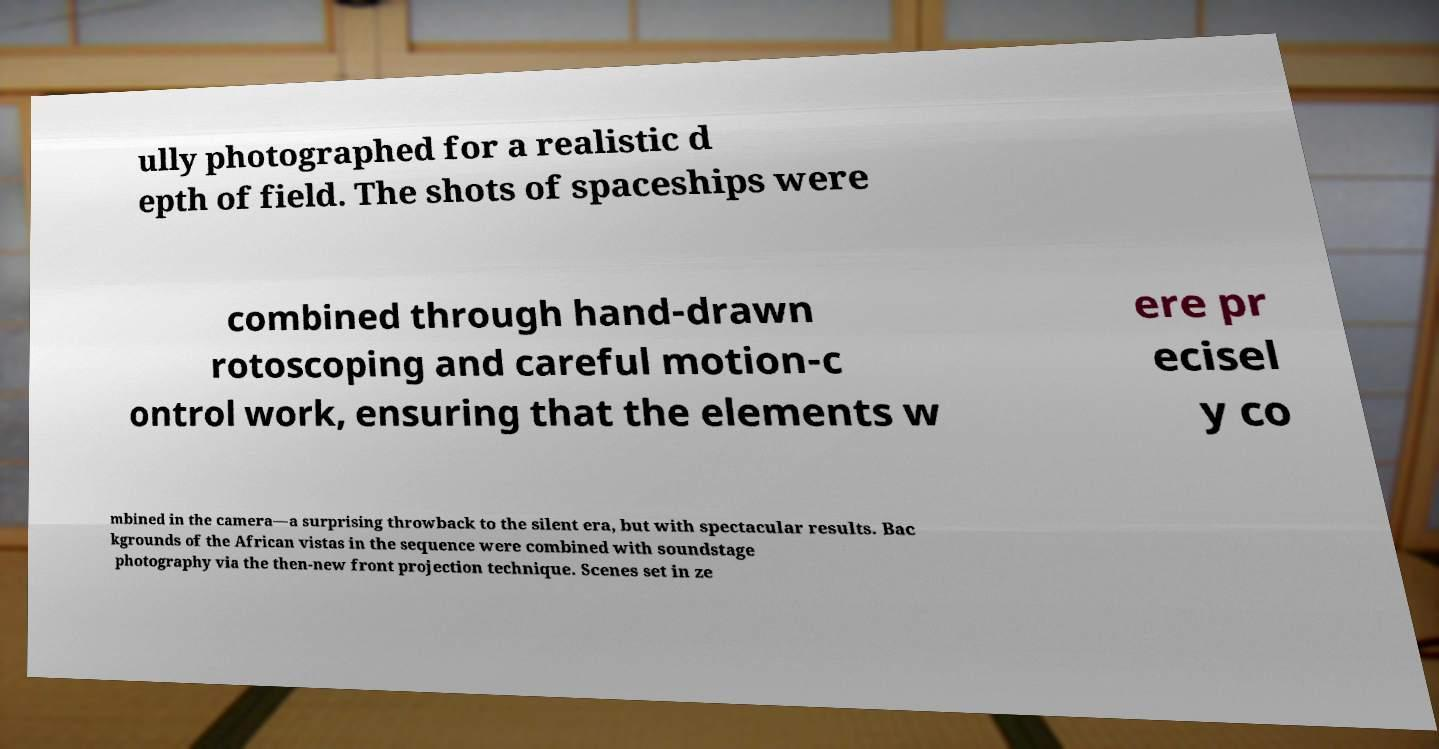Could you assist in decoding the text presented in this image and type it out clearly? ully photographed for a realistic d epth of field. The shots of spaceships were combined through hand-drawn rotoscoping and careful motion-c ontrol work, ensuring that the elements w ere pr ecisel y co mbined in the camera—a surprising throwback to the silent era, but with spectacular results. Bac kgrounds of the African vistas in the sequence were combined with soundstage photography via the then-new front projection technique. Scenes set in ze 